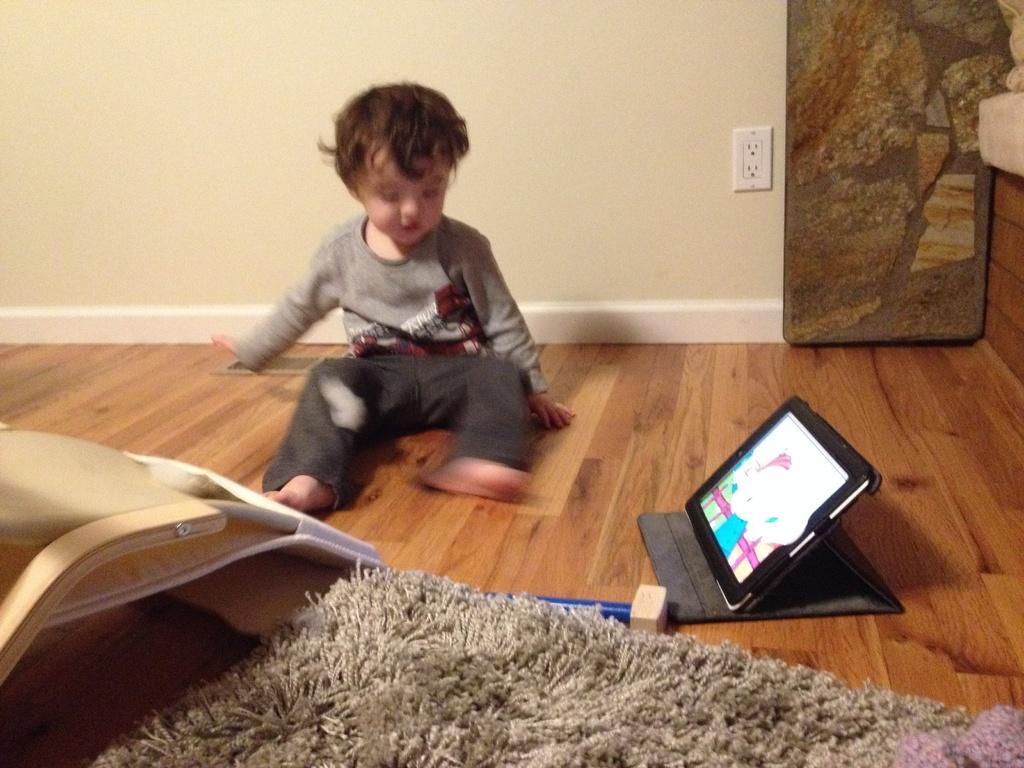Can you describe this image briefly? In this picture we can see a child sitting on the floor. There is a carpet visible at the bottom of the picture. We can see a device and some objects on the floor. There is a switchboard and a wall is visible in the background. 